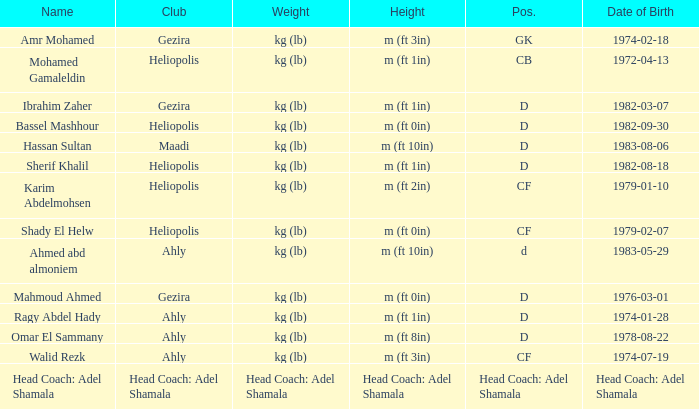What is Date of Birth, when Height is "Head Coach: Adel Shamala"? Head Coach: Adel Shamala. 